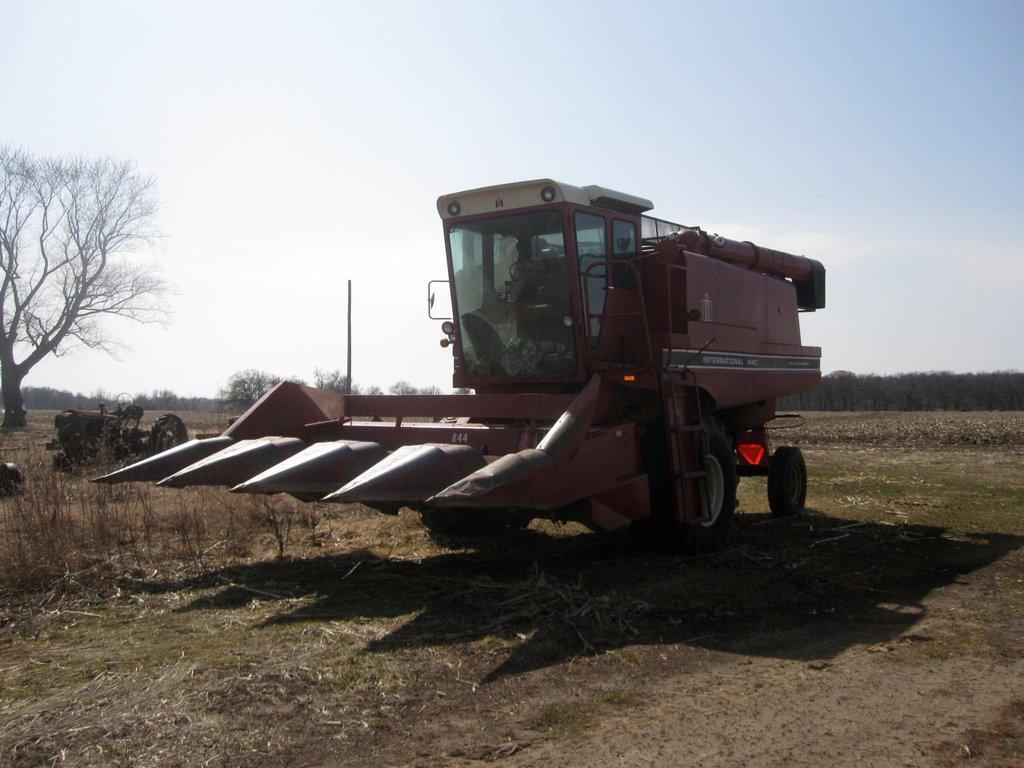How would you summarize this image in a sentence or two? In this image we can see a vehicle on the ground and there are trees and sky at the background. 